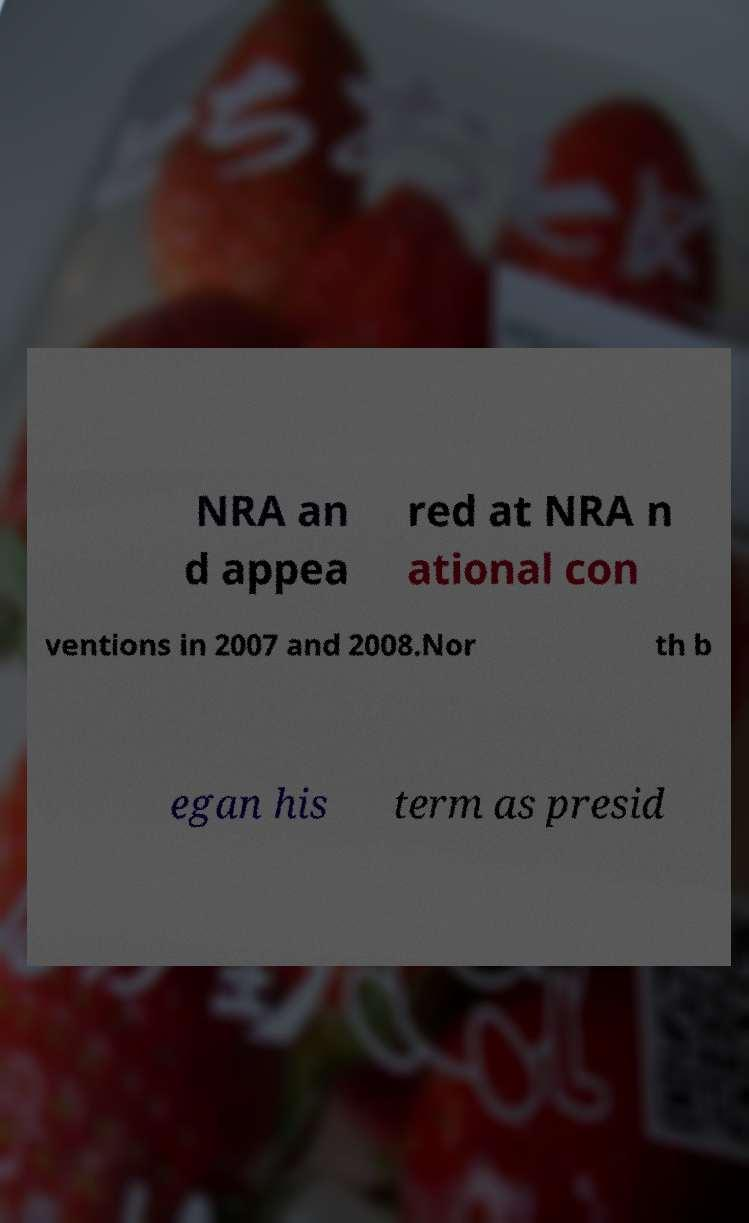What messages or text are displayed in this image? I need them in a readable, typed format. NRA an d appea red at NRA n ational con ventions in 2007 and 2008.Nor th b egan his term as presid 